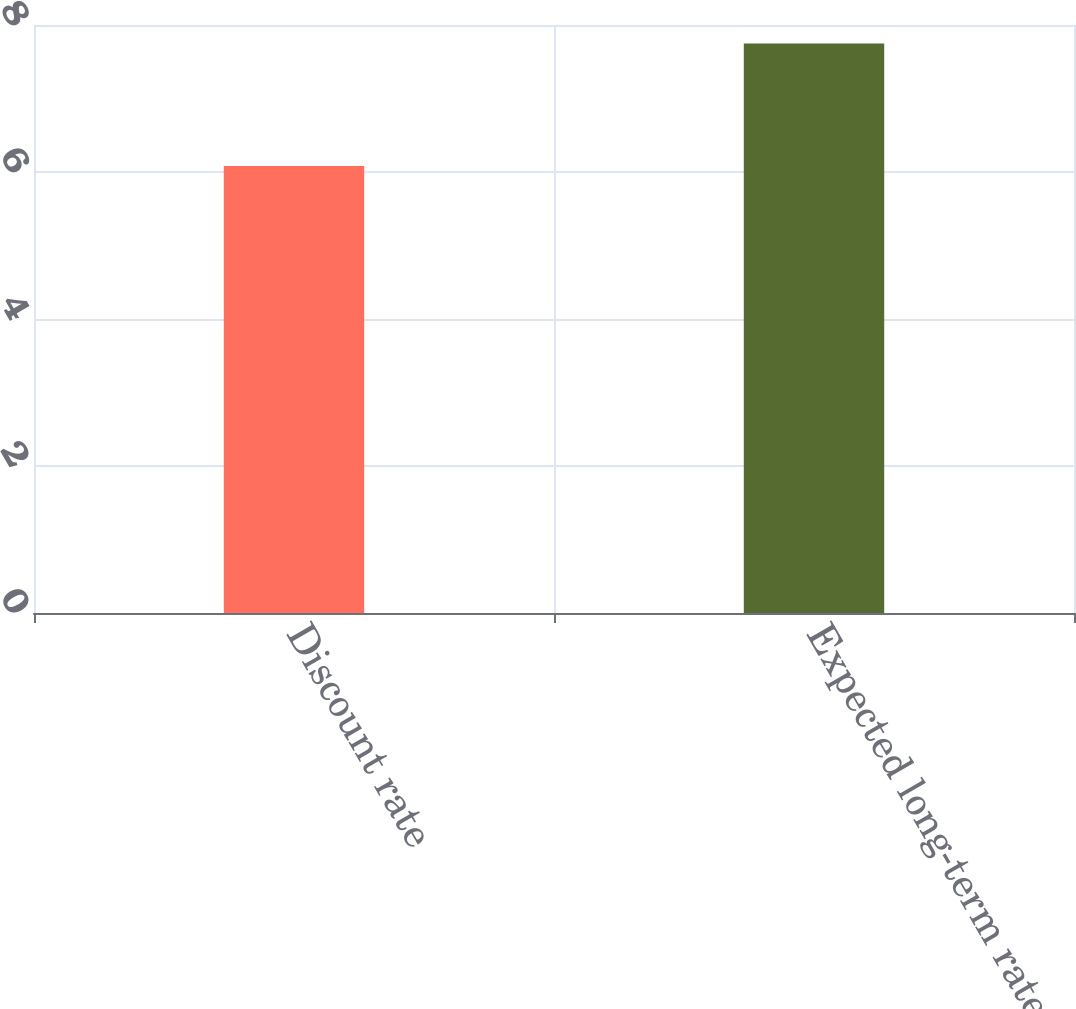Convert chart. <chart><loc_0><loc_0><loc_500><loc_500><bar_chart><fcel>Discount rate<fcel>Expected long-term rate of<nl><fcel>6.08<fcel>7.75<nl></chart> 